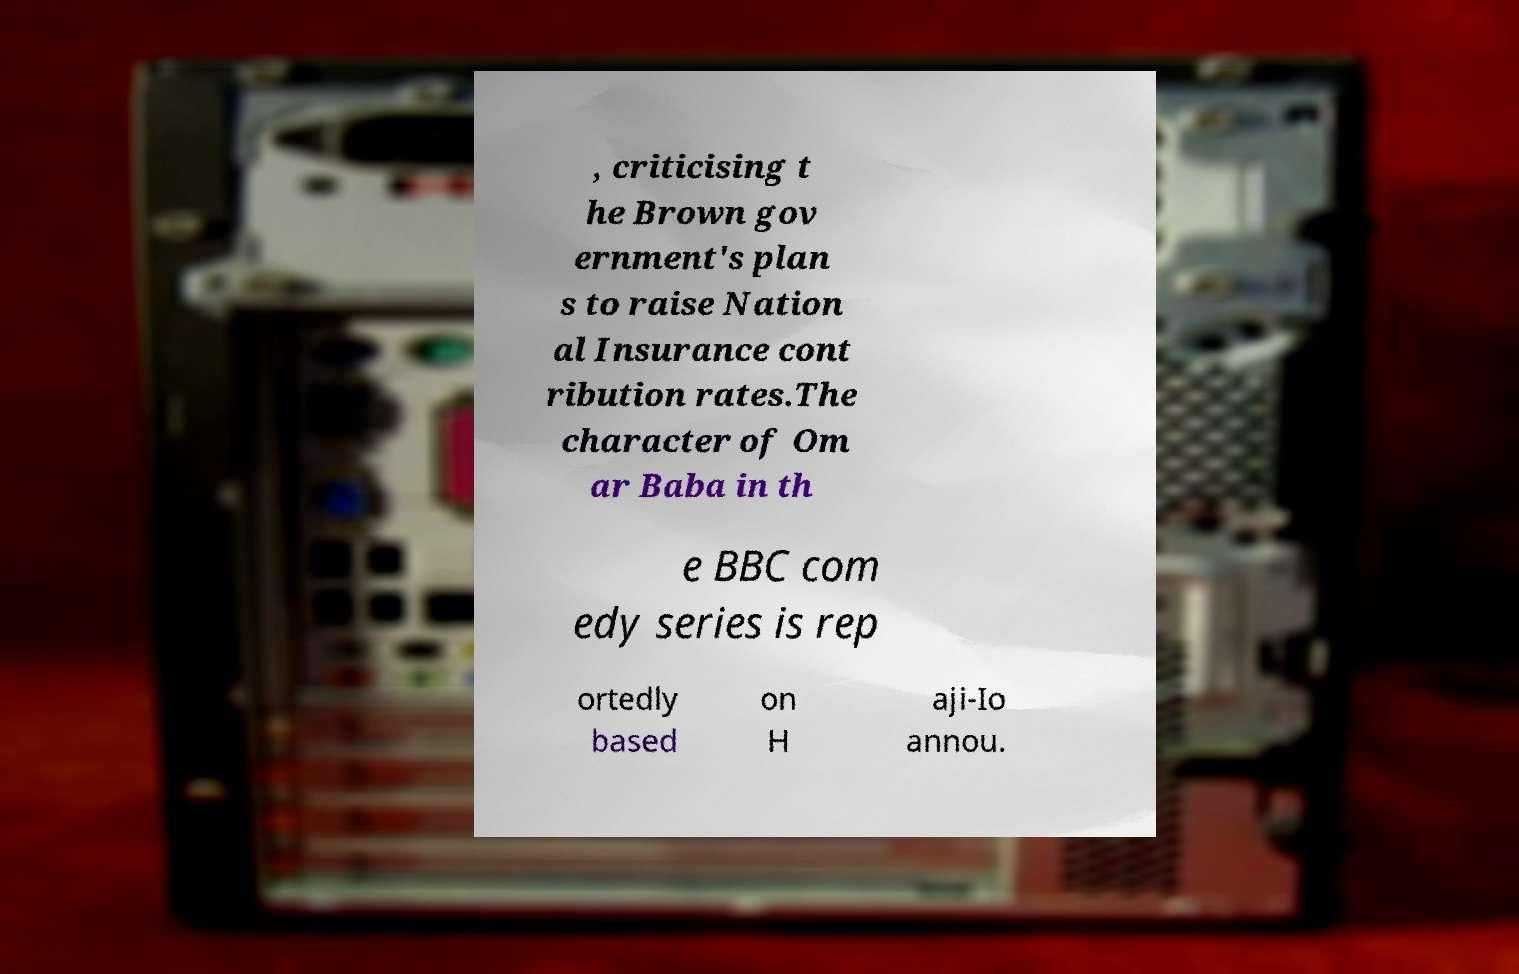What messages or text are displayed in this image? I need them in a readable, typed format. , criticising t he Brown gov ernment's plan s to raise Nation al Insurance cont ribution rates.The character of Om ar Baba in th e BBC com edy series is rep ortedly based on H aji-Io annou. 